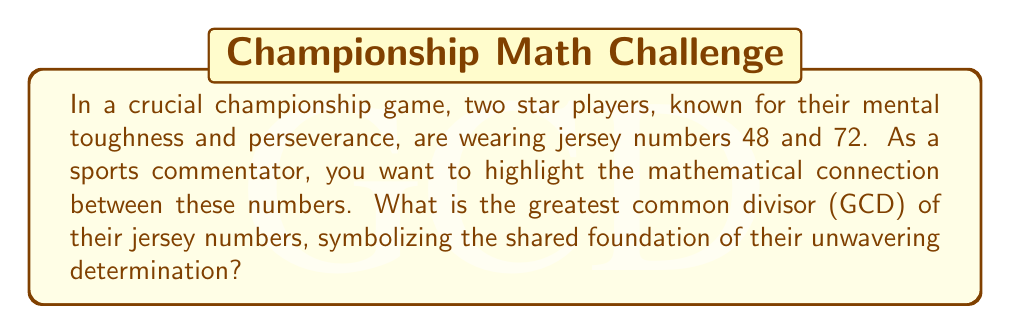Give your solution to this math problem. To find the greatest common divisor (GCD) of 48 and 72, we can use the Euclidean algorithm. This method demonstrates perseverance in mathematics, much like the mental strength these athletes exhibit on the field.

Let's denote GCD(48, 72) as $d$.

Step 1: Set up the initial equation
$$72 = 1 \times 48 + 24$$

Step 2: Continue the process, replacing the larger number with the remainder
$$48 = 2 \times 24 + 0$$

The process stops when we reach a remainder of 0.

Step 3: The last non-zero remainder is the GCD
Therefore, $d = 24$

We can verify this result:
$48 = 2 \times 24$
$72 = 3 \times 24$

Indeed, 24 is the largest number that divides both 48 and 72 without a remainder.

This GCD of 24 symbolizes the common factor of determination and mental strength shared by these two athletes, despite their different jersey numbers.
Answer: The greatest common divisor of the jersey numbers 48 and 72 is 24. 